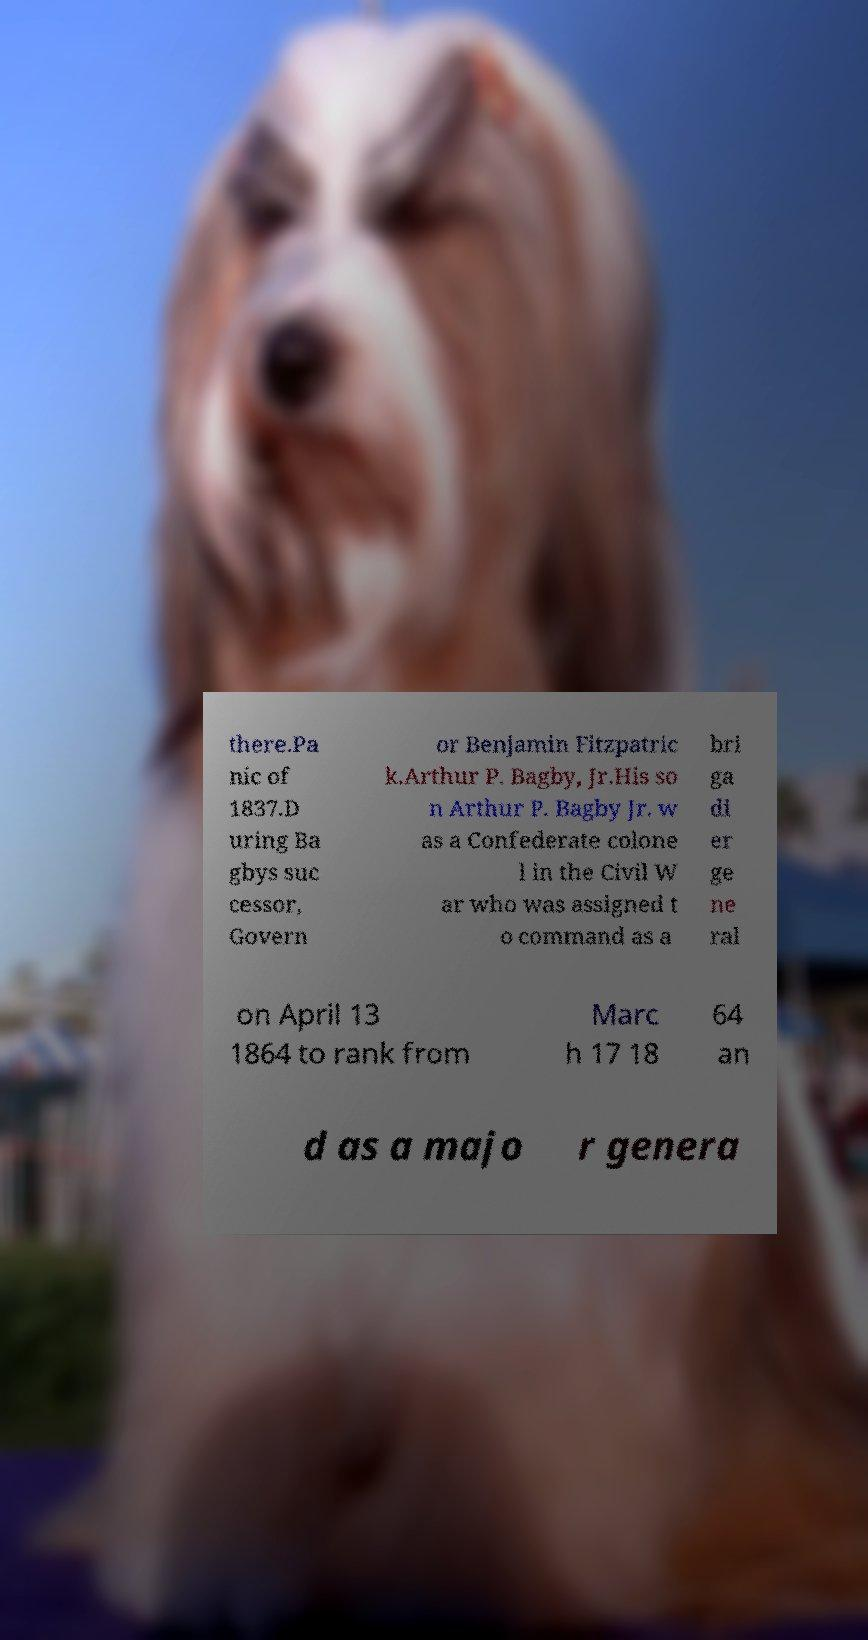Could you assist in decoding the text presented in this image and type it out clearly? there.Pa nic of 1837.D uring Ba gbys suc cessor, Govern or Benjamin Fitzpatric k.Arthur P. Bagby, Jr.His so n Arthur P. Bagby Jr. w as a Confederate colone l in the Civil W ar who was assigned t o command as a bri ga di er ge ne ral on April 13 1864 to rank from Marc h 17 18 64 an d as a majo r genera 